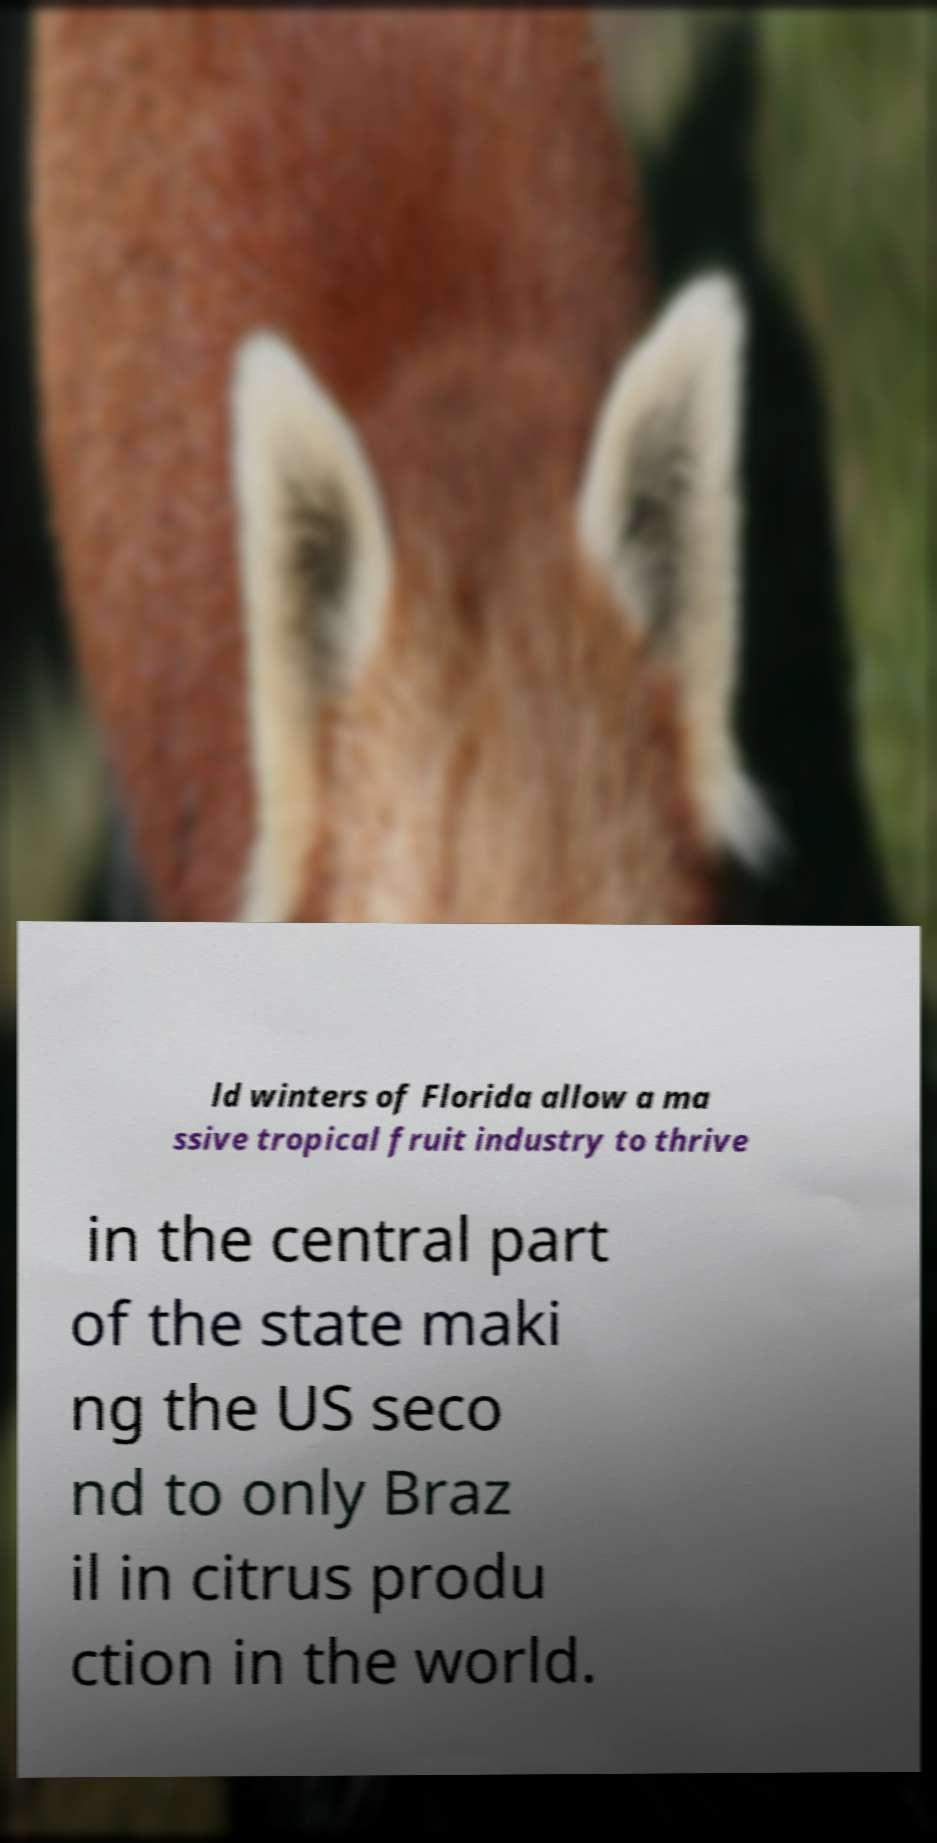Can you read and provide the text displayed in the image?This photo seems to have some interesting text. Can you extract and type it out for me? ld winters of Florida allow a ma ssive tropical fruit industry to thrive in the central part of the state maki ng the US seco nd to only Braz il in citrus produ ction in the world. 